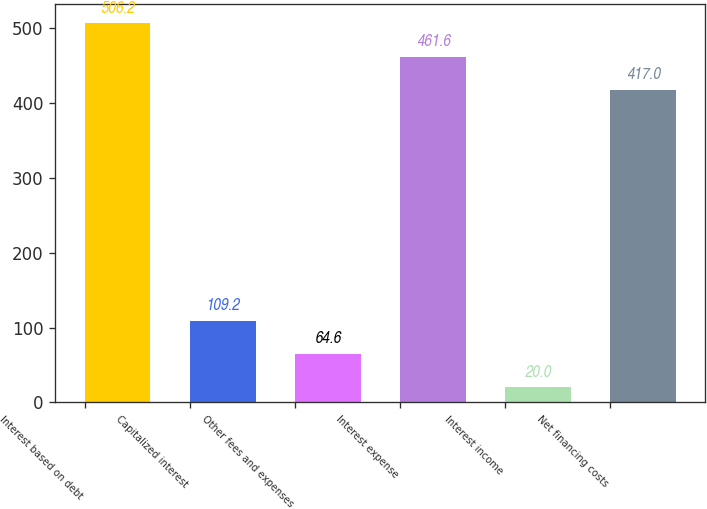Convert chart. <chart><loc_0><loc_0><loc_500><loc_500><bar_chart><fcel>Interest based on debt<fcel>Capitalized interest<fcel>Other fees and expenses<fcel>Interest expense<fcel>Interest income<fcel>Net financing costs<nl><fcel>506.2<fcel>109.2<fcel>64.6<fcel>461.6<fcel>20<fcel>417<nl></chart> 